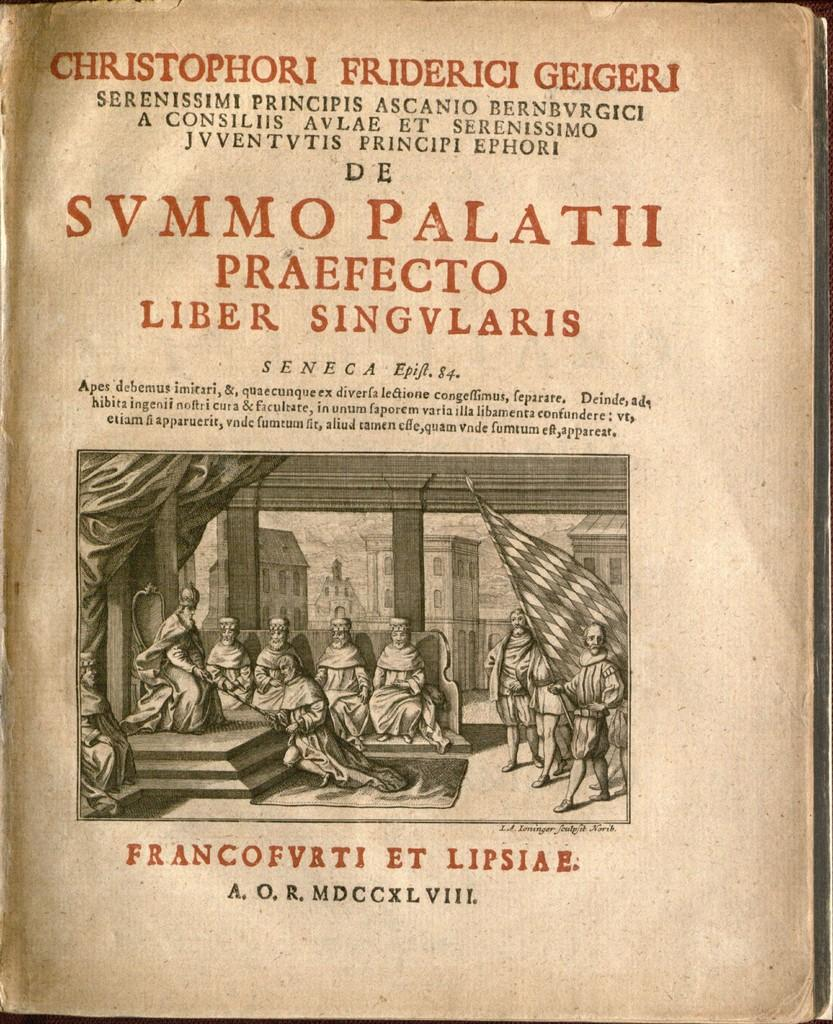<image>
Create a compact narrative representing the image presented. Book open on a page that says "Christophori Friderici Geigeri" on top. 